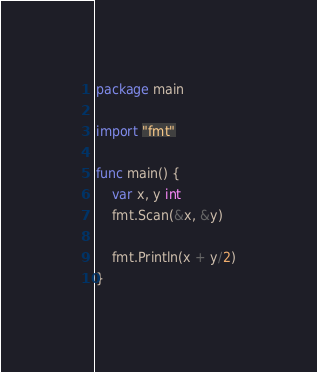<code> <loc_0><loc_0><loc_500><loc_500><_Go_>package main

import "fmt"

func main() {
	var x, y int
	fmt.Scan(&x, &y)

	fmt.Println(x + y/2)
}
</code> 